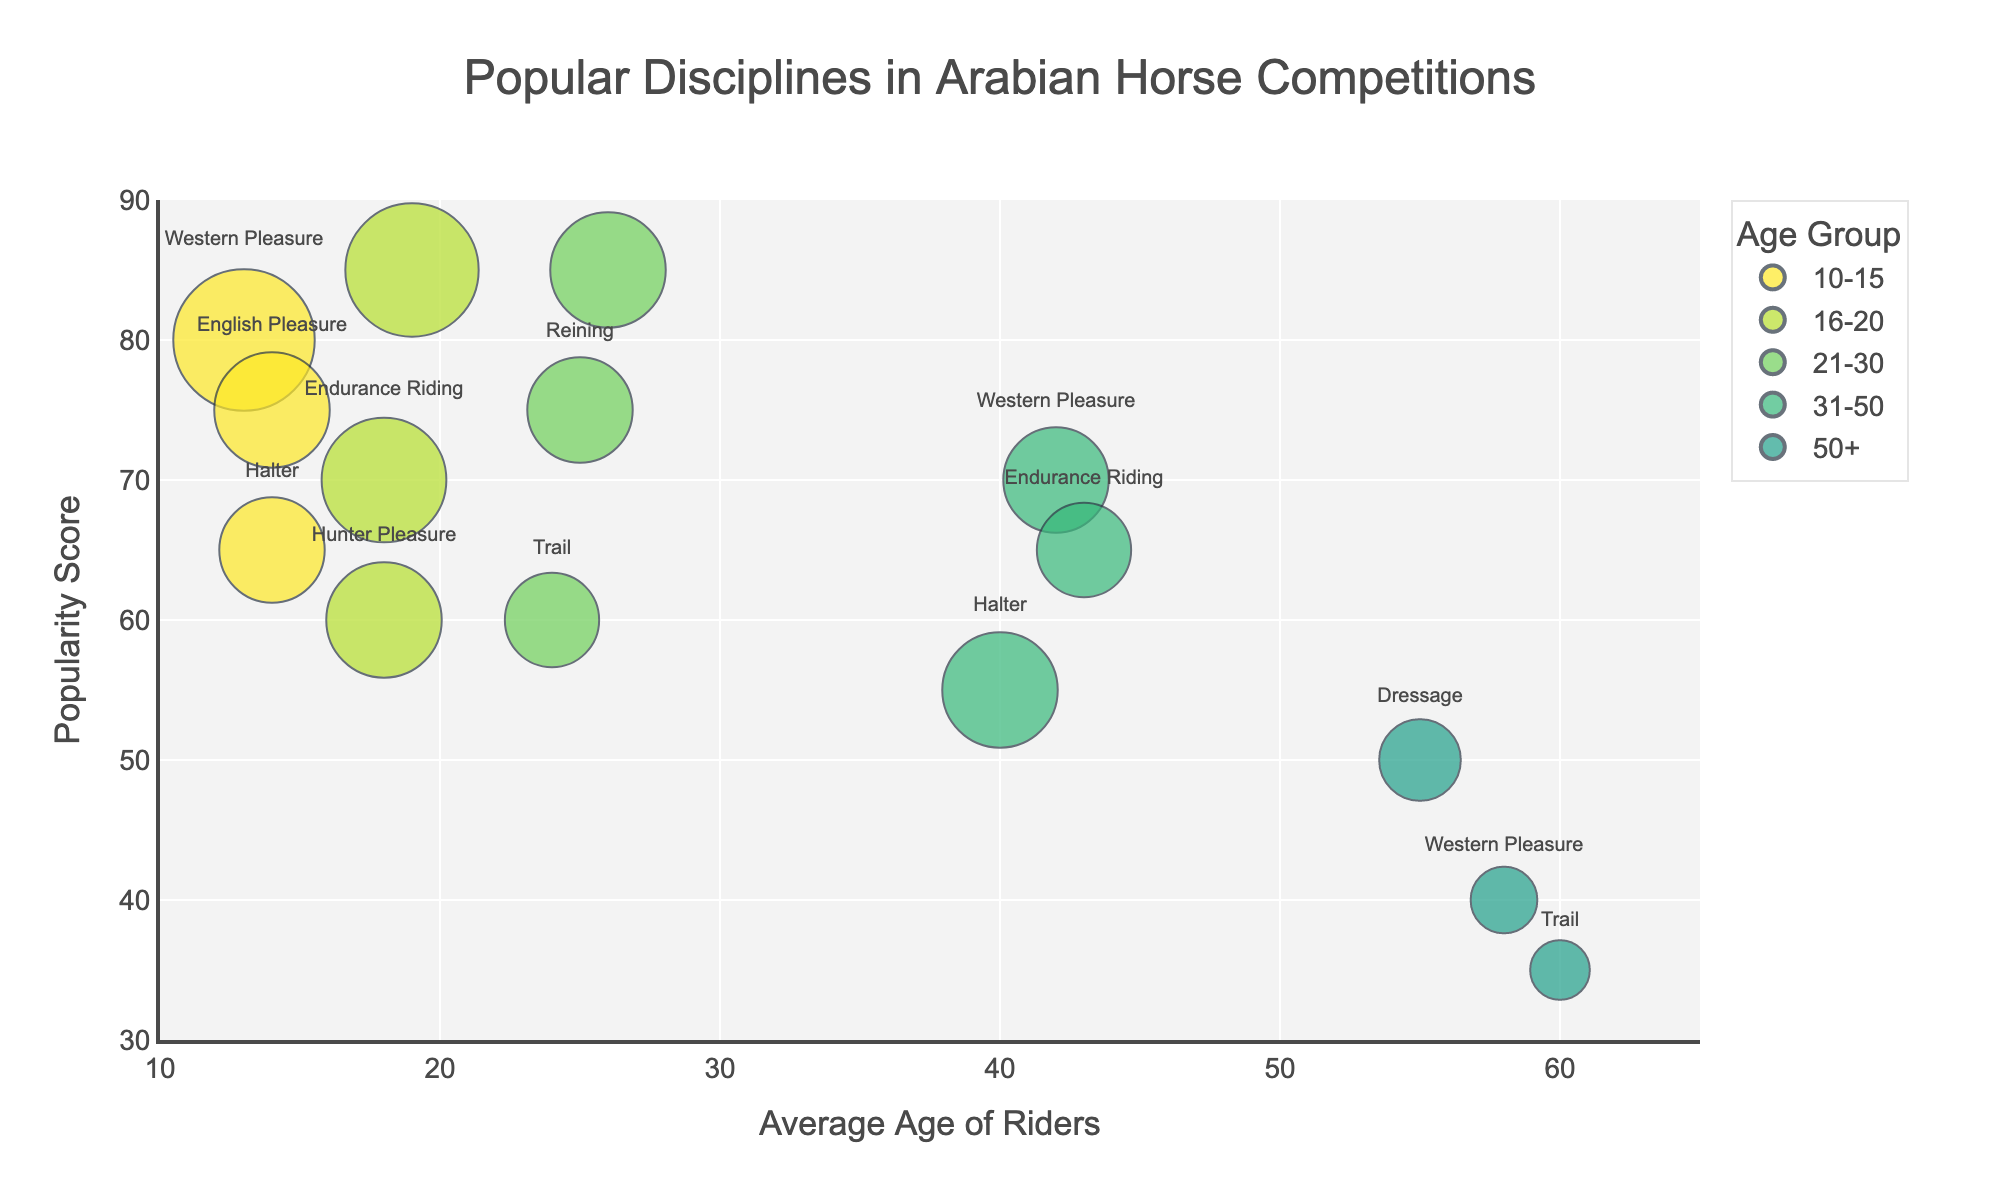What's the title of the figure? The title is usually displayed at the top center of the figure. In this case, the code specifies the title as "Popular Disciplines in Arabian Horse Competitions".
Answer: Popular Disciplines in Arabian Horse Competitions What's the average age range displayed on the x-axis? The x-axis is labeled "Average Age of Riders" and shows a range from 10 to 65. This can be seen by checking the axis's range settings in the figure.
Answer: 10 to 65 Which age group has the highest popularity score in Dressage? By looking at the data points for Dressage, we can identify that the 16-20 age group has a popularity score of 85, which is the highest for Dressage.
Answer: 16-20 Which discipline has the highest popularity score, and what is that score? The bubble representing Show Jumping in the 21-30 age group has the highest y-value, or popularity score, which is 85. This is confirmed by checking the hover text or the data within the figure.
Answer: Show Jumping, 85 How many disciplines are there in the 10-15 age group? By examining the bubble chart and counting the number of data points colored for the 10-15 age group, we find that there are three disciplines: Western Pleasure, English Pleasure, and Halter.
Answer: 3 Which discipline has the largest number of riders and what is that number? The size of the bubbles indicates the number of riders. The largest bubble is Western Pleasure for the 10-15 age group, with 45 riders. This can be verified by checking the hover text.
Answer: Western Pleasure, 45 Compare the popularity scores of Dressage for the 16-20 and 50+ age groups. Which is higher and by how much? The popularity score for Dressage in the 16-20 age group is 85, while for the 50+ age group is 50. The difference can be found by subtracting the lower score from the higher score: 85 - 50 = 35.
Answer: 16-20, by 35 What discipline is most popular among riders aged 50+? By inspecting the bubbles for the 50+ age group, we notice that Dressage has the highest popularity score of 50.
Answer: Dressage What is the discipline with the highest popularity score in the 21-30 age group, and what is its average age? Show Jumping has the highest popularity score of 85 in the 21-30 age group, with an average age of 26. This information is available in the hover text of the largest bubble for this group.
Answer: Show Jumping, 26 